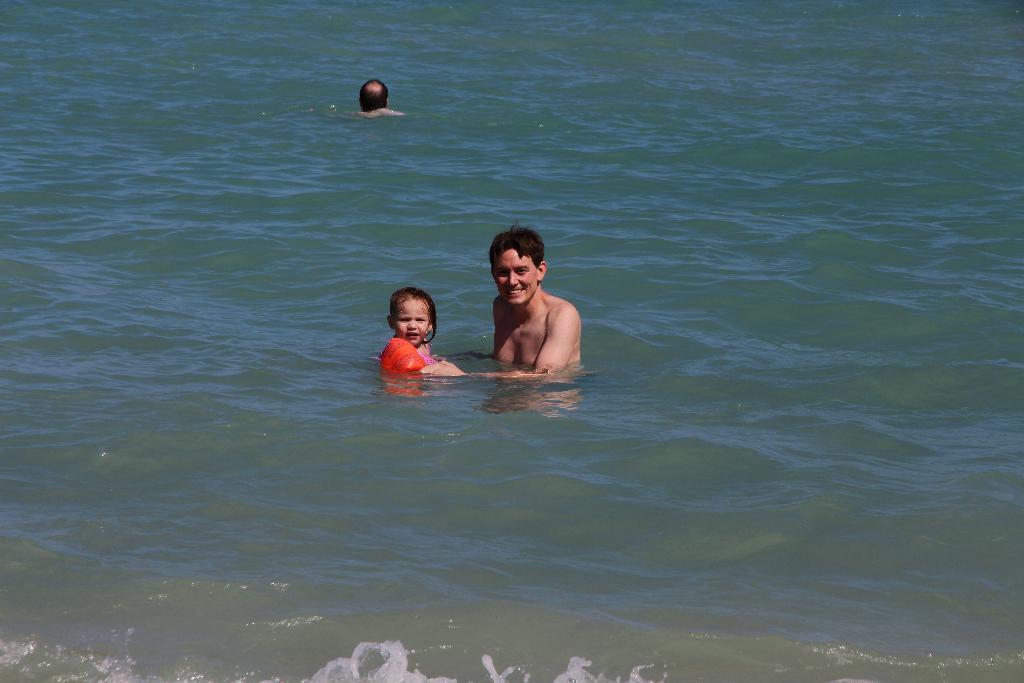Please provide a concise description of this image. In this image I can see the water and a child wearing orange colored dress and two other persons in the water. 